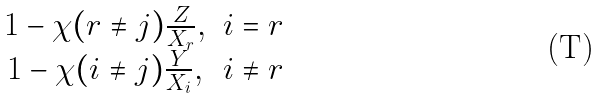Convert formula to latex. <formula><loc_0><loc_0><loc_500><loc_500>\begin{matrix} 1 - \chi ( r \ne j ) \frac { Z } { X _ { r } } , & i = r \\ 1 - \chi ( i \ne j ) \frac { Y } { X _ { i } } , & i \ne r \end{matrix}</formula> 